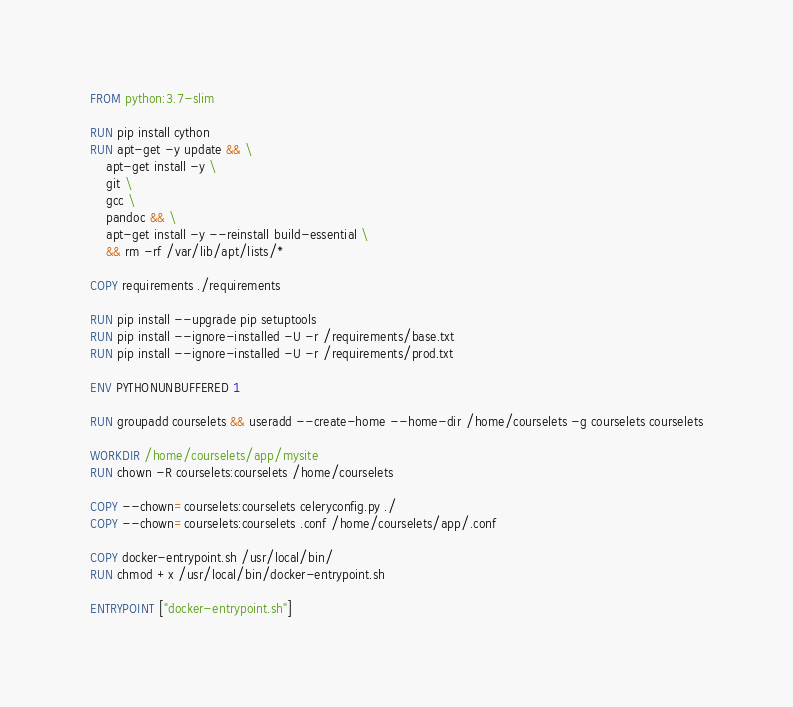<code> <loc_0><loc_0><loc_500><loc_500><_Dockerfile_>FROM python:3.7-slim

RUN pip install cython
RUN apt-get -y update && \
    apt-get install -y \
    git \
    gcc \
    pandoc && \
    apt-get install -y --reinstall build-essential \
    && rm -rf /var/lib/apt/lists/*

COPY requirements ./requirements

RUN pip install --upgrade pip setuptools
RUN pip install --ignore-installed -U -r /requirements/base.txt
RUN pip install --ignore-installed -U -r /requirements/prod.txt

ENV PYTHONUNBUFFERED 1

RUN groupadd courselets && useradd --create-home --home-dir /home/courselets -g courselets courselets

WORKDIR /home/courselets/app/mysite
RUN chown -R courselets:courselets /home/courselets

COPY --chown=courselets:courselets celeryconfig.py ./
COPY --chown=courselets:courselets .conf /home/courselets/app/.conf

COPY docker-entrypoint.sh /usr/local/bin/
RUN chmod +x /usr/local/bin/docker-entrypoint.sh

ENTRYPOINT ["docker-entrypoint.sh"]
</code> 